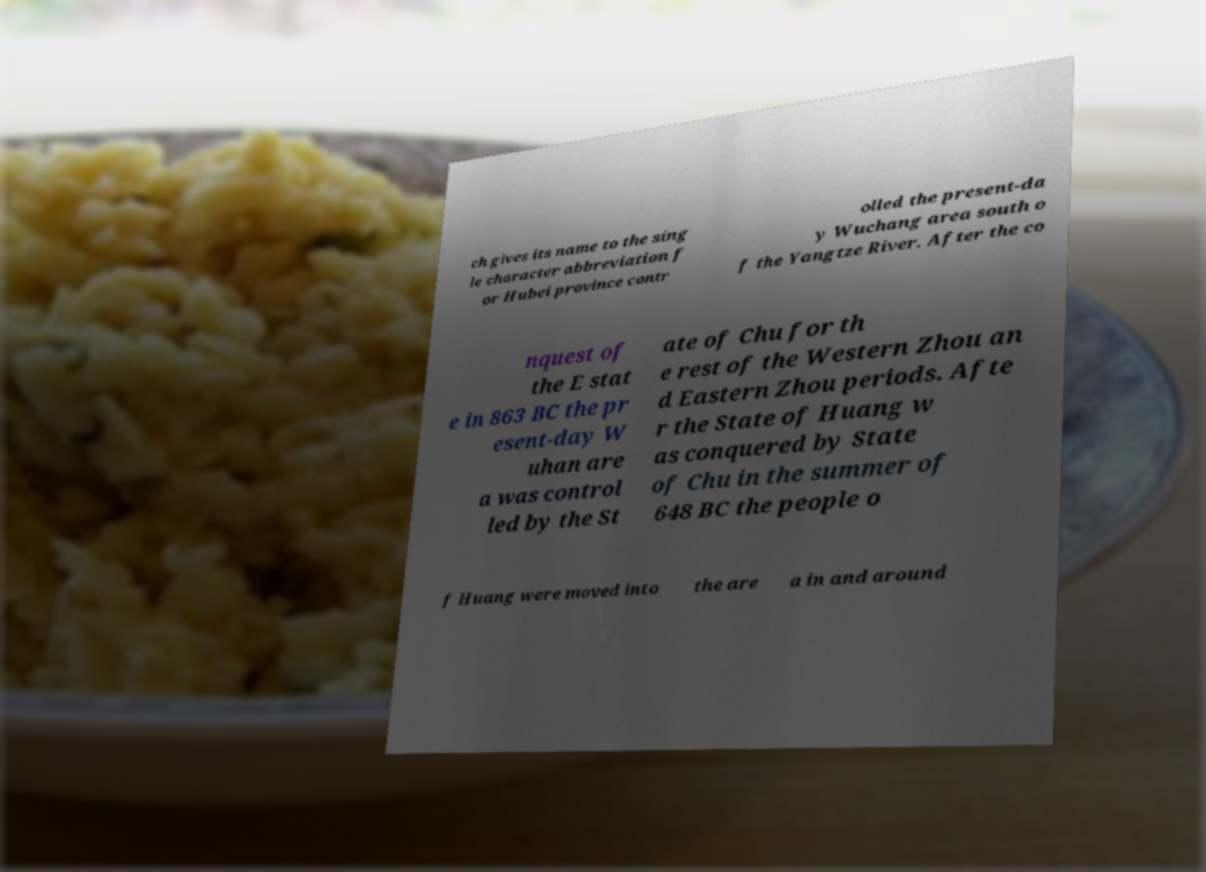For documentation purposes, I need the text within this image transcribed. Could you provide that? ch gives its name to the sing le character abbreviation f or Hubei province contr olled the present-da y Wuchang area south o f the Yangtze River. After the co nquest of the E stat e in 863 BC the pr esent-day W uhan are a was control led by the St ate of Chu for th e rest of the Western Zhou an d Eastern Zhou periods. Afte r the State of Huang w as conquered by State of Chu in the summer of 648 BC the people o f Huang were moved into the are a in and around 